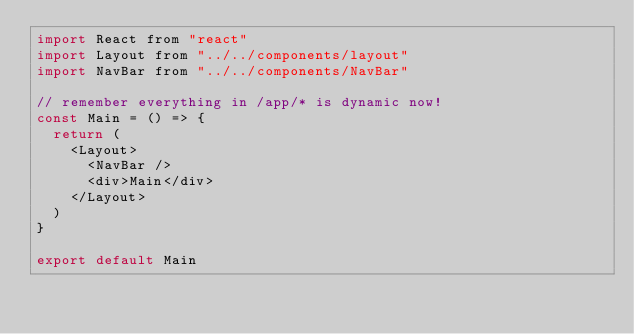Convert code to text. <code><loc_0><loc_0><loc_500><loc_500><_JavaScript_>import React from "react"
import Layout from "../../components/layout"
import NavBar from "../../components/NavBar"

// remember everything in /app/* is dynamic now!
const Main = () => {
  return (
    <Layout>
      <NavBar />
      <div>Main</div>
    </Layout>
  )
}

export default Main
</code> 